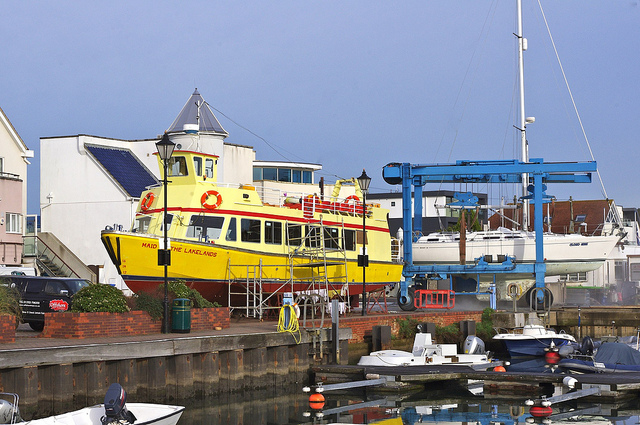<image>Which boat is brighter red and blue? I am not sure which boat is brighter red and blue. There might not be a red and blue boat. How tall is that far building? It is unknown how tall the far building is. The building could be anywhere from 2 to 4 stories tall. Which boat is brighter red and blue? It is ambiguous which boat is brighter red and blue. There is a red boat and a blue boat in the image. How tall is that far building? I don't know how tall that far building is. It can be 50 feet tall, medium, 15 feet, 3 stories, 2 stories, 3 stories, 3 stories, 12, or 4 stories. 